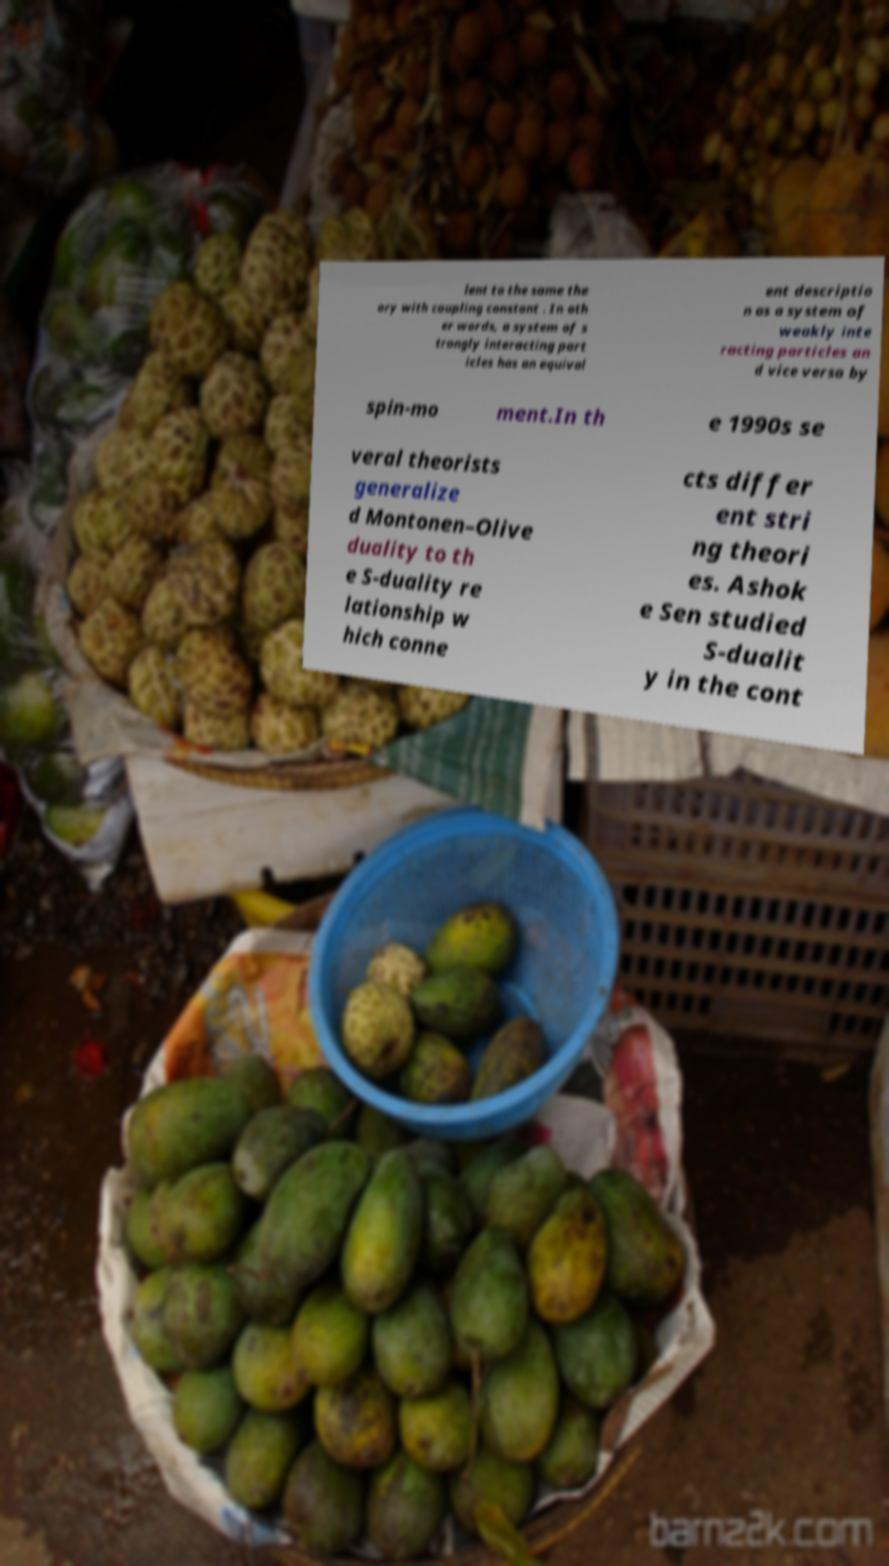Please read and relay the text visible in this image. What does it say? lent to the same the ory with coupling constant . In oth er words, a system of s trongly interacting part icles has an equival ent descriptio n as a system of weakly inte racting particles an d vice versa by spin-mo ment.In th e 1990s se veral theorists generalize d Montonen–Olive duality to th e S-duality re lationship w hich conne cts differ ent stri ng theori es. Ashok e Sen studied S-dualit y in the cont 